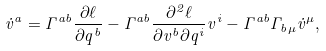Convert formula to latex. <formula><loc_0><loc_0><loc_500><loc_500>\dot { v } ^ { a } = \Gamma ^ { a b } \frac { \partial \ell } { \partial q ^ { b } } - \Gamma ^ { a b } \frac { \partial ^ { 2 } \ell } { \partial v ^ { b } \partial q ^ { i } } v ^ { i } - \Gamma ^ { a b } \Gamma _ { b \mu } \dot { v } ^ { \mu } ,</formula> 